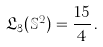<formula> <loc_0><loc_0><loc_500><loc_500>\mathfrak L _ { 3 } ( \mathbb { S } ^ { 2 } ) = \frac { 1 5 } { 4 } \, .</formula> 